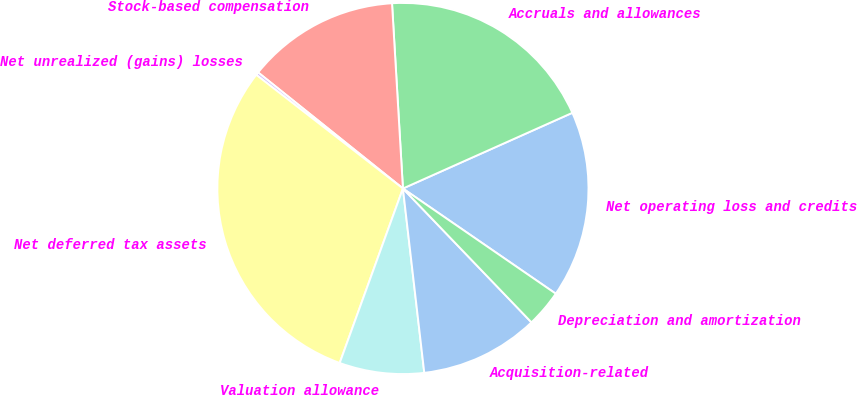<chart> <loc_0><loc_0><loc_500><loc_500><pie_chart><fcel>Net operating loss and credits<fcel>Accruals and allowances<fcel>Stock-based compensation<fcel>Net unrealized (gains) losses<fcel>Net deferred tax assets<fcel>Valuation allowance<fcel>Acquisition-related<fcel>Depreciation and amortization<nl><fcel>16.28%<fcel>19.25%<fcel>13.31%<fcel>0.26%<fcel>29.96%<fcel>7.37%<fcel>10.34%<fcel>3.23%<nl></chart> 